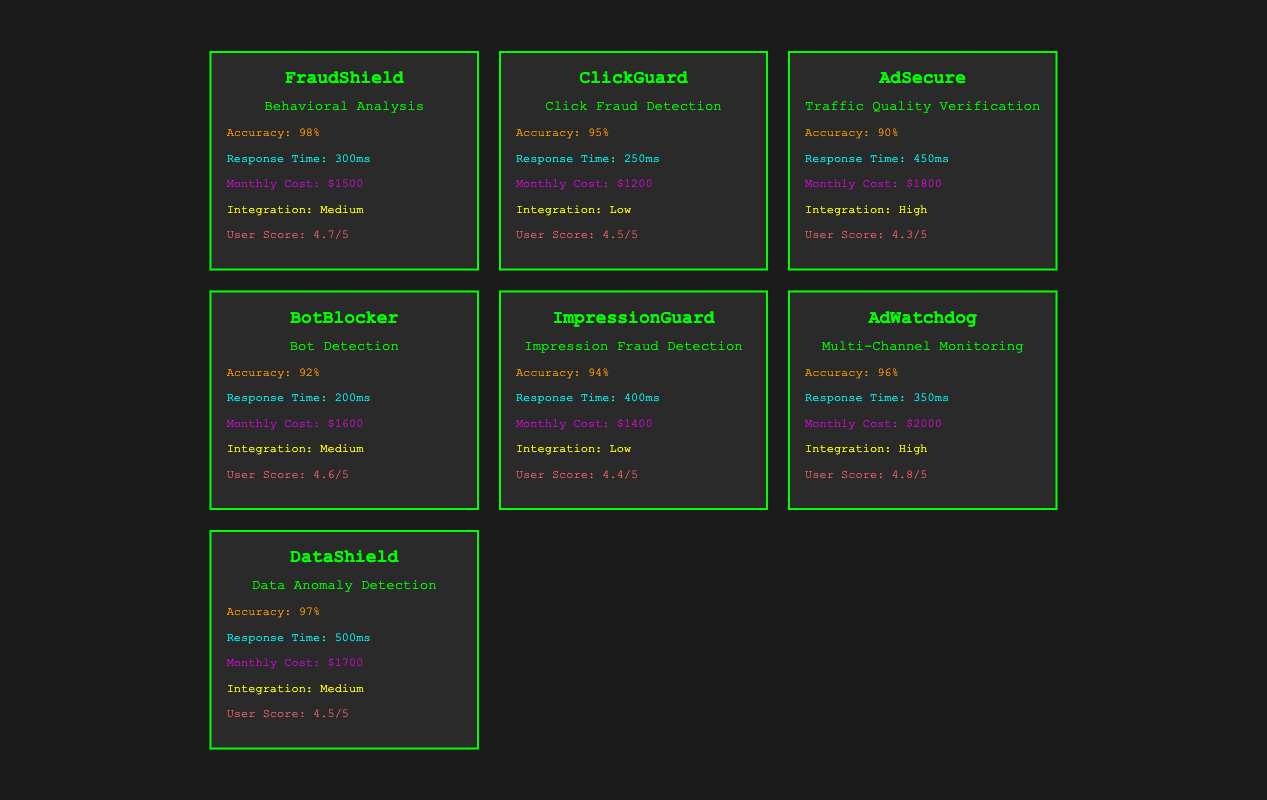What is the monthly cost of BotBlocker? The table lists the monthly costs for all anti-fraud tools. For BotBlocker, the monthly cost is explicitly stated as "$1600".
Answer: $1600 Which tool has the highest user feedback score? Examining the user feedback scores in the table, AdWatchdog has the highest score at "4.8/5".
Answer: 4.8/5 What is the average accuracy of all the anti-fraud tools? The accuracies listed are 98%, 95%, 90%, 92%, 94%, 96%, and 97%. Adding these gives 662%. Dividing by the number of tools (7) results in an average accuracy of 662/7 = 94.57%.
Answer: 94.57% Is the response time of AdSecure faster than that of ImpressionGuard? The table shows AdSecure's response time as "450ms" and ImpressionGuard's as "400ms". Since 450ms is greater than 400ms, AdSecure is not faster.
Answer: No What percentage of tools have a monthly cost over $1500? The tools with a monthly cost over $1500 are AdSecure ($1800), AdWatchdog ($2000), and DataShield ($1700), totaling 3 tools. With a total of 7 tools, the percentage is (3/7)*100 = 42.86%.
Answer: 42.86% Which tool has the lowest integration complexity? The table indicates that both ClickGuard and ImpressionGuard have a "Low" integration complexity, which is the lowest among all tools listed.
Answer: ClickGuard and ImpressionGuard If a company chooses all tools with medium integration complexity, what would be their total monthly cost? The tools with medium integration complexity are FraudShield ($1500), BotBlocker ($1600), and DataShield ($1700). Summing these amounts, we get $1500 + $1600 + $1700 = $4800.
Answer: $4800 How does the response time of FraudShield compare to that of ClickGuard? FraudShield has a response time of "300ms" and ClickGuard has a response time of "250ms". Since 300ms is greater than 250ms, FraudShield has a longer response time.
Answer: FraudShield is longer What is the total score of all user feedback from the tools? The user feedback scores are 4.7, 4.5, 4.3, 4.6, 4.4, 4.8, and 4.5. Summing these scores gives 4.7 + 4.5 + 4.3 + 4.6 + 4.4 + 4.8 + 4.5 = 32.8. Therefore, the total score is 32.8.
Answer: 32.8 